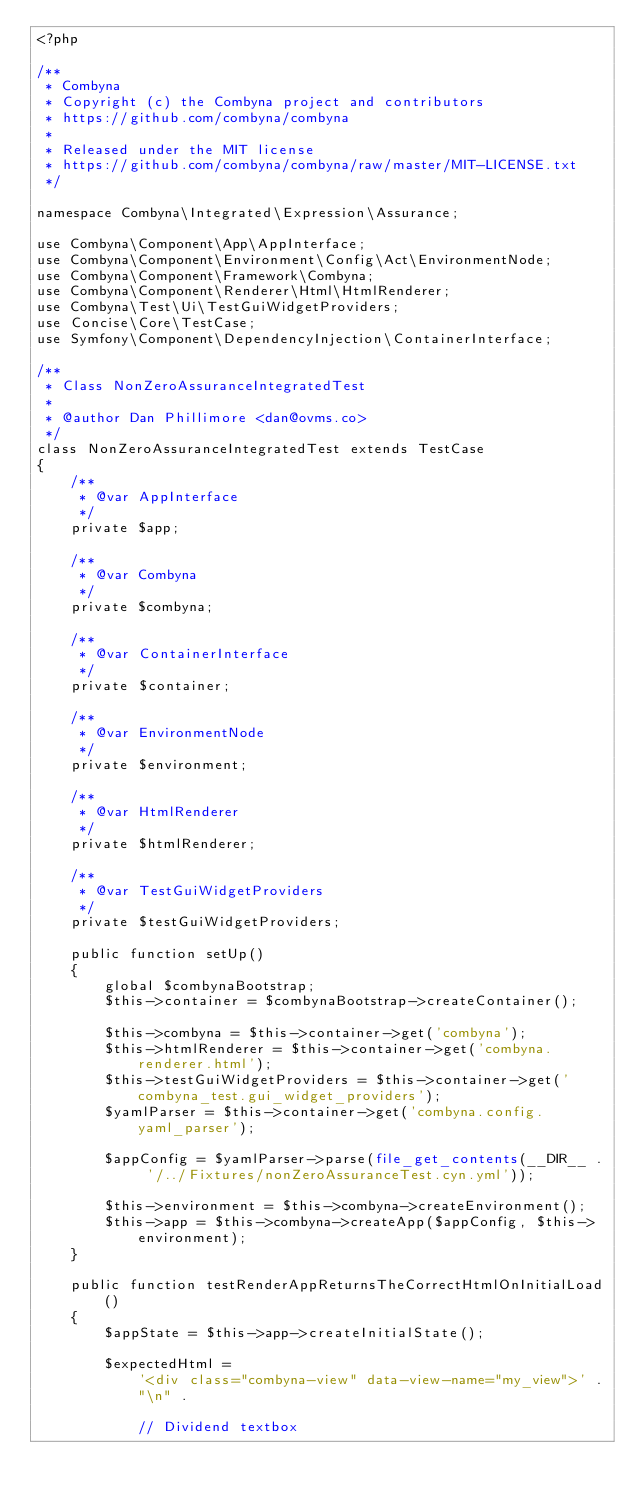Convert code to text. <code><loc_0><loc_0><loc_500><loc_500><_PHP_><?php

/**
 * Combyna
 * Copyright (c) the Combyna project and contributors
 * https://github.com/combyna/combyna
 *
 * Released under the MIT license
 * https://github.com/combyna/combyna/raw/master/MIT-LICENSE.txt
 */

namespace Combyna\Integrated\Expression\Assurance;

use Combyna\Component\App\AppInterface;
use Combyna\Component\Environment\Config\Act\EnvironmentNode;
use Combyna\Component\Framework\Combyna;
use Combyna\Component\Renderer\Html\HtmlRenderer;
use Combyna\Test\Ui\TestGuiWidgetProviders;
use Concise\Core\TestCase;
use Symfony\Component\DependencyInjection\ContainerInterface;

/**
 * Class NonZeroAssuranceIntegratedTest
 *
 * @author Dan Phillimore <dan@ovms.co>
 */
class NonZeroAssuranceIntegratedTest extends TestCase
{
    /**
     * @var AppInterface
     */
    private $app;

    /**
     * @var Combyna
     */
    private $combyna;

    /**
     * @var ContainerInterface
     */
    private $container;

    /**
     * @var EnvironmentNode
     */
    private $environment;

    /**
     * @var HtmlRenderer
     */
    private $htmlRenderer;

    /**
     * @var TestGuiWidgetProviders
     */
    private $testGuiWidgetProviders;

    public function setUp()
    {
        global $combynaBootstrap;
        $this->container = $combynaBootstrap->createContainer();

        $this->combyna = $this->container->get('combyna');
        $this->htmlRenderer = $this->container->get('combyna.renderer.html');
        $this->testGuiWidgetProviders = $this->container->get('combyna_test.gui_widget_providers');
        $yamlParser = $this->container->get('combyna.config.yaml_parser');

        $appConfig = $yamlParser->parse(file_get_contents(__DIR__ . '/../Fixtures/nonZeroAssuranceTest.cyn.yml'));

        $this->environment = $this->combyna->createEnvironment();
        $this->app = $this->combyna->createApp($appConfig, $this->environment);
    }

    public function testRenderAppReturnsTheCorrectHtmlOnInitialLoad()
    {
        $appState = $this->app->createInitialState();

        $expectedHtml =
            '<div class="combyna-view" data-view-name="my_view">' .
            "\n" .

            // Dividend textbox</code> 